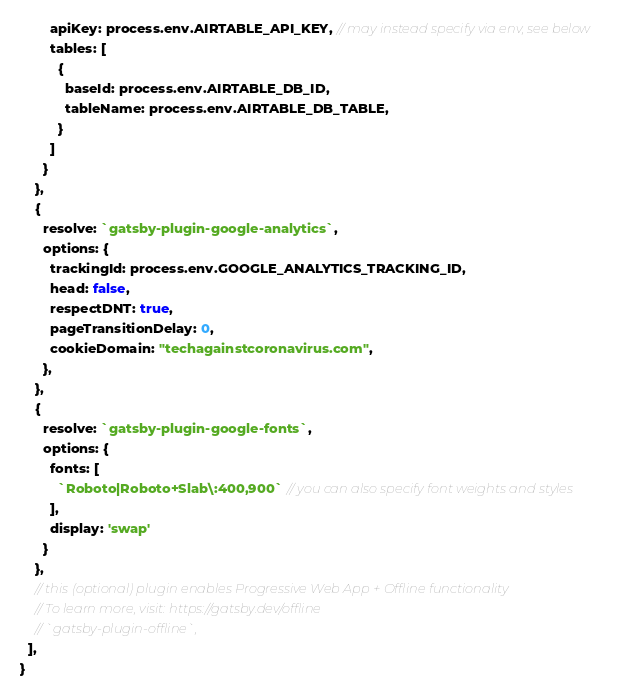Convert code to text. <code><loc_0><loc_0><loc_500><loc_500><_JavaScript_>        apiKey: process.env.AIRTABLE_API_KEY, // may instead specify via env, see below
        tables: [
          {
            baseId: process.env.AIRTABLE_DB_ID,
            tableName: process.env.AIRTABLE_DB_TABLE,
          }
        ]
      }
    },
    {
      resolve: `gatsby-plugin-google-analytics`,
      options: {
        trackingId: process.env.GOOGLE_ANALYTICS_TRACKING_ID,
        head: false,
        respectDNT: true,
        pageTransitionDelay: 0,
        cookieDomain: "techagainstcoronavirus.com",
      },
    },
    {
      resolve: `gatsby-plugin-google-fonts`,
      options: {
        fonts: [
          `Roboto|Roboto+Slab\:400,900` // you can also specify font weights and styles
        ],
        display: 'swap'
      }
    },
    // this (optional) plugin enables Progressive Web App + Offline functionality
    // To learn more, visit: https://gatsby.dev/offline
    // `gatsby-plugin-offline`,
  ],
}
</code> 